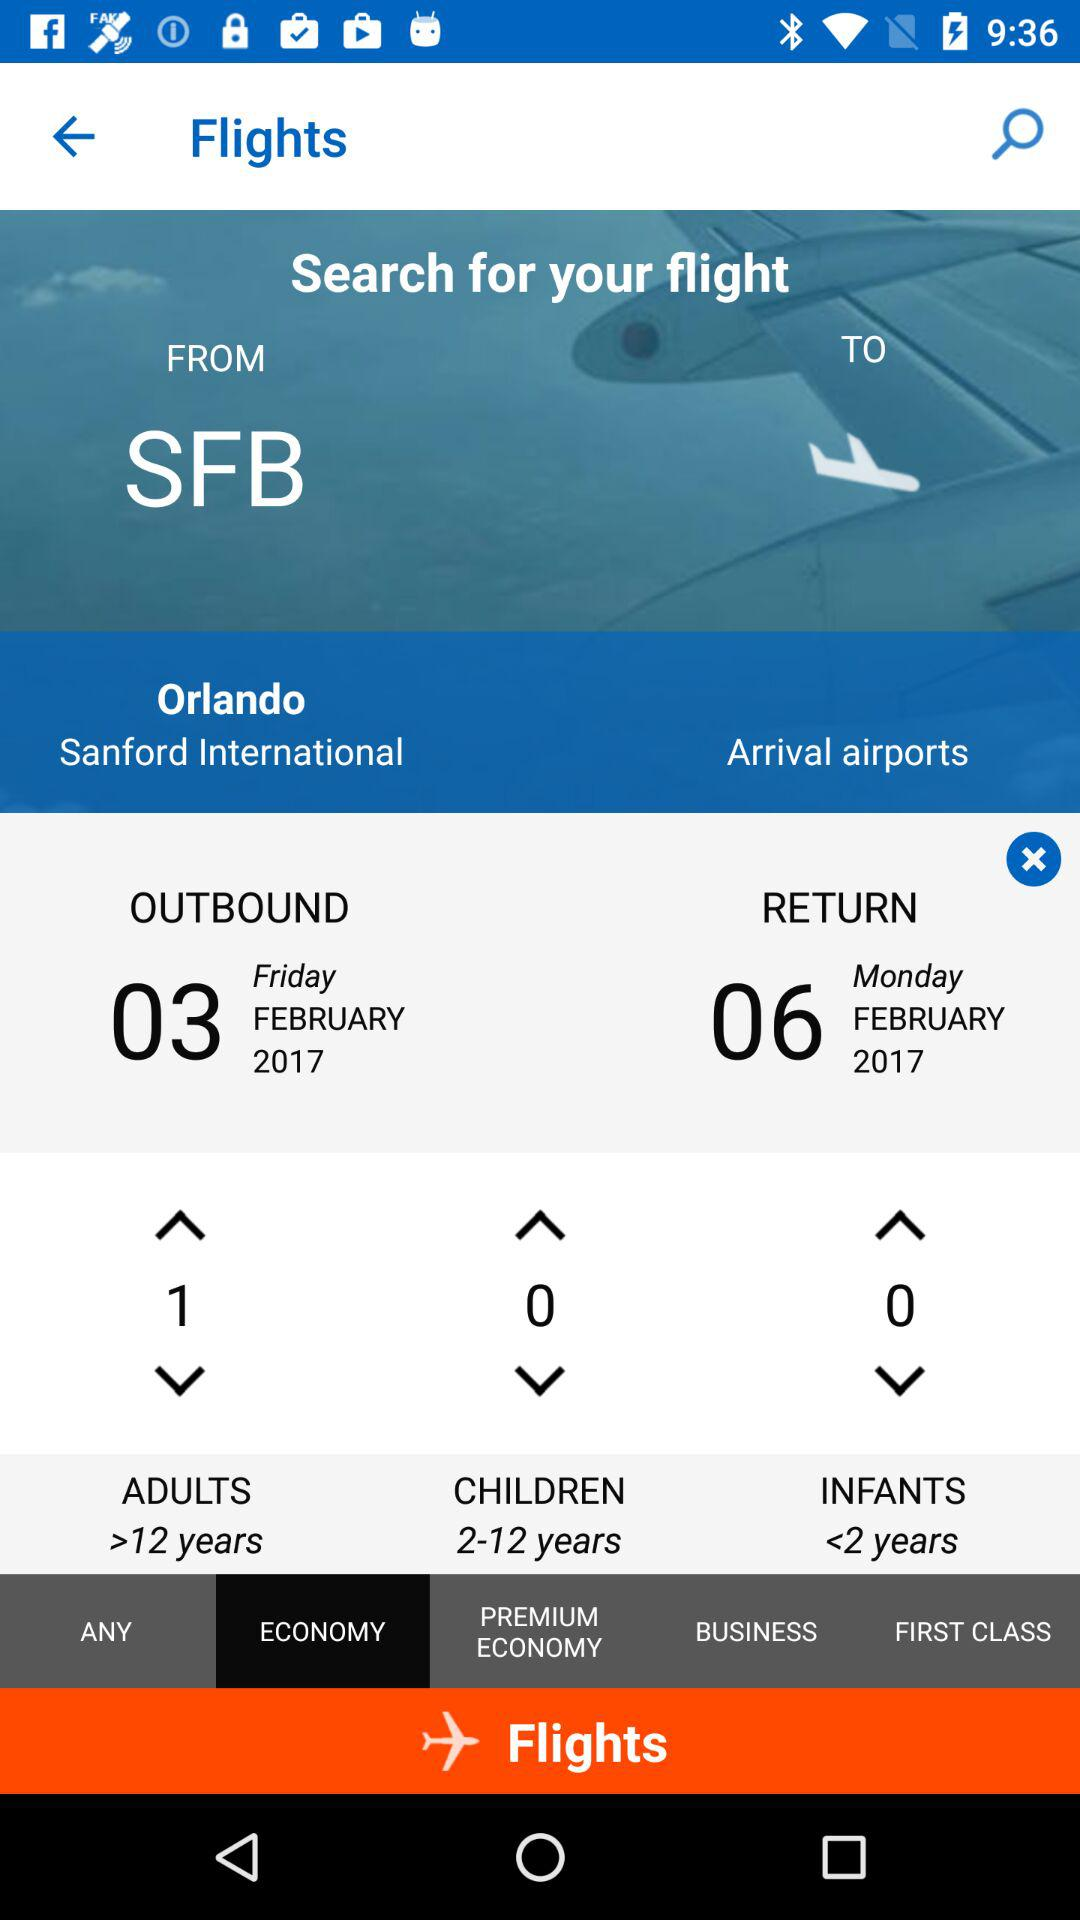What is the maximum age limit of infants?
When the provided information is insufficient, respond with <no answer>. <no answer> 